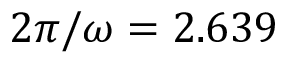<formula> <loc_0><loc_0><loc_500><loc_500>2 \pi / \omega = 2 . 6 3 9</formula> 